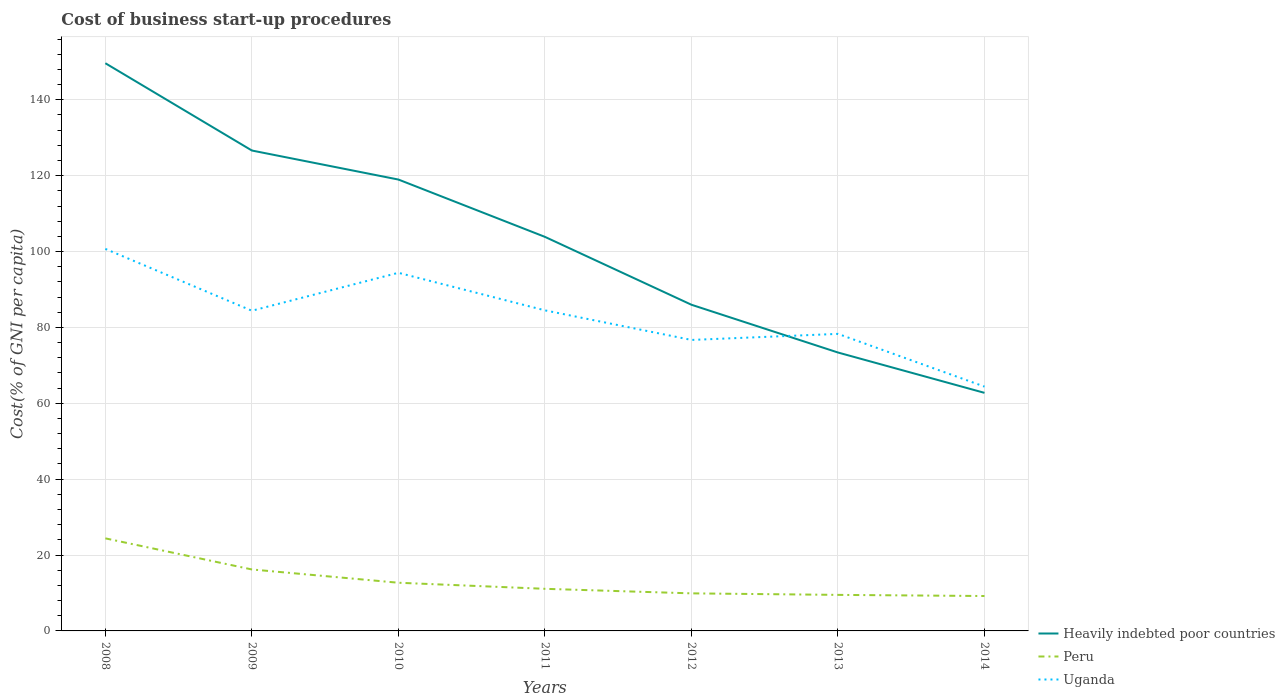Does the line corresponding to Heavily indebted poor countries intersect with the line corresponding to Uganda?
Your answer should be very brief. Yes. Across all years, what is the maximum cost of business start-up procedures in Heavily indebted poor countries?
Ensure brevity in your answer.  62.75. What is the total cost of business start-up procedures in Peru in the graph?
Provide a short and direct response. 7. What is the difference between the highest and the second highest cost of business start-up procedures in Peru?
Provide a succinct answer. 15.2. What is the difference between the highest and the lowest cost of business start-up procedures in Uganda?
Provide a succinct answer. 4. How many years are there in the graph?
Give a very brief answer. 7. Does the graph contain grids?
Provide a short and direct response. Yes. How many legend labels are there?
Your response must be concise. 3. What is the title of the graph?
Offer a terse response. Cost of business start-up procedures. Does "Guam" appear as one of the legend labels in the graph?
Your response must be concise. No. What is the label or title of the Y-axis?
Your answer should be compact. Cost(% of GNI per capita). What is the Cost(% of GNI per capita) in Heavily indebted poor countries in 2008?
Your answer should be compact. 149.64. What is the Cost(% of GNI per capita) of Peru in 2008?
Make the answer very short. 24.4. What is the Cost(% of GNI per capita) of Uganda in 2008?
Your response must be concise. 100.7. What is the Cost(% of GNI per capita) in Heavily indebted poor countries in 2009?
Provide a short and direct response. 126.63. What is the Cost(% of GNI per capita) of Peru in 2009?
Offer a very short reply. 16.2. What is the Cost(% of GNI per capita) of Uganda in 2009?
Ensure brevity in your answer.  84.4. What is the Cost(% of GNI per capita) in Heavily indebted poor countries in 2010?
Your answer should be compact. 118.98. What is the Cost(% of GNI per capita) in Uganda in 2010?
Your answer should be compact. 94.4. What is the Cost(% of GNI per capita) in Heavily indebted poor countries in 2011?
Offer a very short reply. 103.87. What is the Cost(% of GNI per capita) in Peru in 2011?
Your answer should be very brief. 11.1. What is the Cost(% of GNI per capita) in Uganda in 2011?
Give a very brief answer. 84.5. What is the Cost(% of GNI per capita) in Heavily indebted poor countries in 2012?
Offer a terse response. 85.98. What is the Cost(% of GNI per capita) of Uganda in 2012?
Offer a terse response. 76.7. What is the Cost(% of GNI per capita) of Heavily indebted poor countries in 2013?
Ensure brevity in your answer.  73.39. What is the Cost(% of GNI per capita) in Peru in 2013?
Your response must be concise. 9.5. What is the Cost(% of GNI per capita) in Uganda in 2013?
Your answer should be compact. 78.3. What is the Cost(% of GNI per capita) in Heavily indebted poor countries in 2014?
Ensure brevity in your answer.  62.75. What is the Cost(% of GNI per capita) of Peru in 2014?
Ensure brevity in your answer.  9.2. What is the Cost(% of GNI per capita) in Uganda in 2014?
Provide a succinct answer. 64.4. Across all years, what is the maximum Cost(% of GNI per capita) in Heavily indebted poor countries?
Ensure brevity in your answer.  149.64. Across all years, what is the maximum Cost(% of GNI per capita) in Peru?
Provide a succinct answer. 24.4. Across all years, what is the maximum Cost(% of GNI per capita) of Uganda?
Ensure brevity in your answer.  100.7. Across all years, what is the minimum Cost(% of GNI per capita) of Heavily indebted poor countries?
Your answer should be compact. 62.75. Across all years, what is the minimum Cost(% of GNI per capita) in Peru?
Provide a succinct answer. 9.2. Across all years, what is the minimum Cost(% of GNI per capita) of Uganda?
Offer a terse response. 64.4. What is the total Cost(% of GNI per capita) in Heavily indebted poor countries in the graph?
Your response must be concise. 721.24. What is the total Cost(% of GNI per capita) in Peru in the graph?
Keep it short and to the point. 93. What is the total Cost(% of GNI per capita) in Uganda in the graph?
Make the answer very short. 583.4. What is the difference between the Cost(% of GNI per capita) of Heavily indebted poor countries in 2008 and that in 2009?
Make the answer very short. 23.01. What is the difference between the Cost(% of GNI per capita) of Peru in 2008 and that in 2009?
Provide a succinct answer. 8.2. What is the difference between the Cost(% of GNI per capita) of Heavily indebted poor countries in 2008 and that in 2010?
Ensure brevity in your answer.  30.66. What is the difference between the Cost(% of GNI per capita) of Uganda in 2008 and that in 2010?
Your response must be concise. 6.3. What is the difference between the Cost(% of GNI per capita) of Heavily indebted poor countries in 2008 and that in 2011?
Your answer should be very brief. 45.77. What is the difference between the Cost(% of GNI per capita) of Heavily indebted poor countries in 2008 and that in 2012?
Provide a succinct answer. 63.67. What is the difference between the Cost(% of GNI per capita) of Peru in 2008 and that in 2012?
Provide a succinct answer. 14.5. What is the difference between the Cost(% of GNI per capita) in Heavily indebted poor countries in 2008 and that in 2013?
Provide a short and direct response. 76.26. What is the difference between the Cost(% of GNI per capita) of Peru in 2008 and that in 2013?
Offer a very short reply. 14.9. What is the difference between the Cost(% of GNI per capita) in Uganda in 2008 and that in 2013?
Your answer should be very brief. 22.4. What is the difference between the Cost(% of GNI per capita) of Heavily indebted poor countries in 2008 and that in 2014?
Your answer should be very brief. 86.89. What is the difference between the Cost(% of GNI per capita) of Peru in 2008 and that in 2014?
Offer a terse response. 15.2. What is the difference between the Cost(% of GNI per capita) of Uganda in 2008 and that in 2014?
Your answer should be compact. 36.3. What is the difference between the Cost(% of GNI per capita) in Heavily indebted poor countries in 2009 and that in 2010?
Provide a short and direct response. 7.65. What is the difference between the Cost(% of GNI per capita) in Heavily indebted poor countries in 2009 and that in 2011?
Your answer should be compact. 22.76. What is the difference between the Cost(% of GNI per capita) of Peru in 2009 and that in 2011?
Offer a terse response. 5.1. What is the difference between the Cost(% of GNI per capita) in Uganda in 2009 and that in 2011?
Make the answer very short. -0.1. What is the difference between the Cost(% of GNI per capita) in Heavily indebted poor countries in 2009 and that in 2012?
Your answer should be very brief. 40.65. What is the difference between the Cost(% of GNI per capita) of Peru in 2009 and that in 2012?
Your answer should be compact. 6.3. What is the difference between the Cost(% of GNI per capita) in Heavily indebted poor countries in 2009 and that in 2013?
Make the answer very short. 53.24. What is the difference between the Cost(% of GNI per capita) of Heavily indebted poor countries in 2009 and that in 2014?
Give a very brief answer. 63.88. What is the difference between the Cost(% of GNI per capita) of Peru in 2009 and that in 2014?
Ensure brevity in your answer.  7. What is the difference between the Cost(% of GNI per capita) of Heavily indebted poor countries in 2010 and that in 2011?
Keep it short and to the point. 15.11. What is the difference between the Cost(% of GNI per capita) of Uganda in 2010 and that in 2011?
Provide a succinct answer. 9.9. What is the difference between the Cost(% of GNI per capita) of Heavily indebted poor countries in 2010 and that in 2012?
Offer a terse response. 33. What is the difference between the Cost(% of GNI per capita) of Peru in 2010 and that in 2012?
Ensure brevity in your answer.  2.8. What is the difference between the Cost(% of GNI per capita) in Uganda in 2010 and that in 2012?
Provide a succinct answer. 17.7. What is the difference between the Cost(% of GNI per capita) of Heavily indebted poor countries in 2010 and that in 2013?
Offer a very short reply. 45.59. What is the difference between the Cost(% of GNI per capita) in Peru in 2010 and that in 2013?
Your response must be concise. 3.2. What is the difference between the Cost(% of GNI per capita) of Heavily indebted poor countries in 2010 and that in 2014?
Offer a very short reply. 56.23. What is the difference between the Cost(% of GNI per capita) in Heavily indebted poor countries in 2011 and that in 2012?
Offer a terse response. 17.89. What is the difference between the Cost(% of GNI per capita) in Heavily indebted poor countries in 2011 and that in 2013?
Ensure brevity in your answer.  30.48. What is the difference between the Cost(% of GNI per capita) of Uganda in 2011 and that in 2013?
Provide a short and direct response. 6.2. What is the difference between the Cost(% of GNI per capita) of Heavily indebted poor countries in 2011 and that in 2014?
Your answer should be compact. 41.12. What is the difference between the Cost(% of GNI per capita) in Peru in 2011 and that in 2014?
Make the answer very short. 1.9. What is the difference between the Cost(% of GNI per capita) in Uganda in 2011 and that in 2014?
Make the answer very short. 20.1. What is the difference between the Cost(% of GNI per capita) of Heavily indebted poor countries in 2012 and that in 2013?
Ensure brevity in your answer.  12.59. What is the difference between the Cost(% of GNI per capita) of Peru in 2012 and that in 2013?
Provide a succinct answer. 0.4. What is the difference between the Cost(% of GNI per capita) in Heavily indebted poor countries in 2012 and that in 2014?
Provide a succinct answer. 23.22. What is the difference between the Cost(% of GNI per capita) in Peru in 2012 and that in 2014?
Your answer should be compact. 0.7. What is the difference between the Cost(% of GNI per capita) of Uganda in 2012 and that in 2014?
Provide a short and direct response. 12.3. What is the difference between the Cost(% of GNI per capita) of Heavily indebted poor countries in 2013 and that in 2014?
Give a very brief answer. 10.63. What is the difference between the Cost(% of GNI per capita) of Peru in 2013 and that in 2014?
Your answer should be compact. 0.3. What is the difference between the Cost(% of GNI per capita) in Heavily indebted poor countries in 2008 and the Cost(% of GNI per capita) in Peru in 2009?
Your answer should be compact. 133.44. What is the difference between the Cost(% of GNI per capita) in Heavily indebted poor countries in 2008 and the Cost(% of GNI per capita) in Uganda in 2009?
Offer a terse response. 65.24. What is the difference between the Cost(% of GNI per capita) in Peru in 2008 and the Cost(% of GNI per capita) in Uganda in 2009?
Provide a succinct answer. -60. What is the difference between the Cost(% of GNI per capita) of Heavily indebted poor countries in 2008 and the Cost(% of GNI per capita) of Peru in 2010?
Make the answer very short. 136.94. What is the difference between the Cost(% of GNI per capita) in Heavily indebted poor countries in 2008 and the Cost(% of GNI per capita) in Uganda in 2010?
Make the answer very short. 55.24. What is the difference between the Cost(% of GNI per capita) of Peru in 2008 and the Cost(% of GNI per capita) of Uganda in 2010?
Your response must be concise. -70. What is the difference between the Cost(% of GNI per capita) of Heavily indebted poor countries in 2008 and the Cost(% of GNI per capita) of Peru in 2011?
Your answer should be compact. 138.54. What is the difference between the Cost(% of GNI per capita) of Heavily indebted poor countries in 2008 and the Cost(% of GNI per capita) of Uganda in 2011?
Your response must be concise. 65.14. What is the difference between the Cost(% of GNI per capita) in Peru in 2008 and the Cost(% of GNI per capita) in Uganda in 2011?
Offer a very short reply. -60.1. What is the difference between the Cost(% of GNI per capita) of Heavily indebted poor countries in 2008 and the Cost(% of GNI per capita) of Peru in 2012?
Offer a terse response. 139.74. What is the difference between the Cost(% of GNI per capita) in Heavily indebted poor countries in 2008 and the Cost(% of GNI per capita) in Uganda in 2012?
Provide a succinct answer. 72.94. What is the difference between the Cost(% of GNI per capita) of Peru in 2008 and the Cost(% of GNI per capita) of Uganda in 2012?
Ensure brevity in your answer.  -52.3. What is the difference between the Cost(% of GNI per capita) of Heavily indebted poor countries in 2008 and the Cost(% of GNI per capita) of Peru in 2013?
Provide a succinct answer. 140.14. What is the difference between the Cost(% of GNI per capita) in Heavily indebted poor countries in 2008 and the Cost(% of GNI per capita) in Uganda in 2013?
Your answer should be very brief. 71.34. What is the difference between the Cost(% of GNI per capita) in Peru in 2008 and the Cost(% of GNI per capita) in Uganda in 2013?
Provide a succinct answer. -53.9. What is the difference between the Cost(% of GNI per capita) in Heavily indebted poor countries in 2008 and the Cost(% of GNI per capita) in Peru in 2014?
Your response must be concise. 140.44. What is the difference between the Cost(% of GNI per capita) in Heavily indebted poor countries in 2008 and the Cost(% of GNI per capita) in Uganda in 2014?
Keep it short and to the point. 85.24. What is the difference between the Cost(% of GNI per capita) in Heavily indebted poor countries in 2009 and the Cost(% of GNI per capita) in Peru in 2010?
Keep it short and to the point. 113.93. What is the difference between the Cost(% of GNI per capita) of Heavily indebted poor countries in 2009 and the Cost(% of GNI per capita) of Uganda in 2010?
Ensure brevity in your answer.  32.23. What is the difference between the Cost(% of GNI per capita) of Peru in 2009 and the Cost(% of GNI per capita) of Uganda in 2010?
Give a very brief answer. -78.2. What is the difference between the Cost(% of GNI per capita) in Heavily indebted poor countries in 2009 and the Cost(% of GNI per capita) in Peru in 2011?
Make the answer very short. 115.53. What is the difference between the Cost(% of GNI per capita) in Heavily indebted poor countries in 2009 and the Cost(% of GNI per capita) in Uganda in 2011?
Give a very brief answer. 42.13. What is the difference between the Cost(% of GNI per capita) of Peru in 2009 and the Cost(% of GNI per capita) of Uganda in 2011?
Ensure brevity in your answer.  -68.3. What is the difference between the Cost(% of GNI per capita) of Heavily indebted poor countries in 2009 and the Cost(% of GNI per capita) of Peru in 2012?
Provide a short and direct response. 116.73. What is the difference between the Cost(% of GNI per capita) in Heavily indebted poor countries in 2009 and the Cost(% of GNI per capita) in Uganda in 2012?
Ensure brevity in your answer.  49.93. What is the difference between the Cost(% of GNI per capita) of Peru in 2009 and the Cost(% of GNI per capita) of Uganda in 2012?
Your answer should be compact. -60.5. What is the difference between the Cost(% of GNI per capita) of Heavily indebted poor countries in 2009 and the Cost(% of GNI per capita) of Peru in 2013?
Make the answer very short. 117.13. What is the difference between the Cost(% of GNI per capita) in Heavily indebted poor countries in 2009 and the Cost(% of GNI per capita) in Uganda in 2013?
Provide a short and direct response. 48.33. What is the difference between the Cost(% of GNI per capita) in Peru in 2009 and the Cost(% of GNI per capita) in Uganda in 2013?
Offer a very short reply. -62.1. What is the difference between the Cost(% of GNI per capita) of Heavily indebted poor countries in 2009 and the Cost(% of GNI per capita) of Peru in 2014?
Provide a succinct answer. 117.43. What is the difference between the Cost(% of GNI per capita) in Heavily indebted poor countries in 2009 and the Cost(% of GNI per capita) in Uganda in 2014?
Offer a terse response. 62.23. What is the difference between the Cost(% of GNI per capita) in Peru in 2009 and the Cost(% of GNI per capita) in Uganda in 2014?
Make the answer very short. -48.2. What is the difference between the Cost(% of GNI per capita) of Heavily indebted poor countries in 2010 and the Cost(% of GNI per capita) of Peru in 2011?
Provide a succinct answer. 107.88. What is the difference between the Cost(% of GNI per capita) in Heavily indebted poor countries in 2010 and the Cost(% of GNI per capita) in Uganda in 2011?
Your answer should be very brief. 34.48. What is the difference between the Cost(% of GNI per capita) in Peru in 2010 and the Cost(% of GNI per capita) in Uganda in 2011?
Make the answer very short. -71.8. What is the difference between the Cost(% of GNI per capita) of Heavily indebted poor countries in 2010 and the Cost(% of GNI per capita) of Peru in 2012?
Make the answer very short. 109.08. What is the difference between the Cost(% of GNI per capita) of Heavily indebted poor countries in 2010 and the Cost(% of GNI per capita) of Uganda in 2012?
Your response must be concise. 42.28. What is the difference between the Cost(% of GNI per capita) in Peru in 2010 and the Cost(% of GNI per capita) in Uganda in 2012?
Your response must be concise. -64. What is the difference between the Cost(% of GNI per capita) of Heavily indebted poor countries in 2010 and the Cost(% of GNI per capita) of Peru in 2013?
Offer a terse response. 109.48. What is the difference between the Cost(% of GNI per capita) in Heavily indebted poor countries in 2010 and the Cost(% of GNI per capita) in Uganda in 2013?
Offer a very short reply. 40.68. What is the difference between the Cost(% of GNI per capita) of Peru in 2010 and the Cost(% of GNI per capita) of Uganda in 2013?
Ensure brevity in your answer.  -65.6. What is the difference between the Cost(% of GNI per capita) in Heavily indebted poor countries in 2010 and the Cost(% of GNI per capita) in Peru in 2014?
Your answer should be very brief. 109.78. What is the difference between the Cost(% of GNI per capita) in Heavily indebted poor countries in 2010 and the Cost(% of GNI per capita) in Uganda in 2014?
Ensure brevity in your answer.  54.58. What is the difference between the Cost(% of GNI per capita) of Peru in 2010 and the Cost(% of GNI per capita) of Uganda in 2014?
Offer a very short reply. -51.7. What is the difference between the Cost(% of GNI per capita) in Heavily indebted poor countries in 2011 and the Cost(% of GNI per capita) in Peru in 2012?
Ensure brevity in your answer.  93.97. What is the difference between the Cost(% of GNI per capita) in Heavily indebted poor countries in 2011 and the Cost(% of GNI per capita) in Uganda in 2012?
Provide a short and direct response. 27.17. What is the difference between the Cost(% of GNI per capita) in Peru in 2011 and the Cost(% of GNI per capita) in Uganda in 2012?
Offer a very short reply. -65.6. What is the difference between the Cost(% of GNI per capita) of Heavily indebted poor countries in 2011 and the Cost(% of GNI per capita) of Peru in 2013?
Ensure brevity in your answer.  94.37. What is the difference between the Cost(% of GNI per capita) in Heavily indebted poor countries in 2011 and the Cost(% of GNI per capita) in Uganda in 2013?
Your answer should be compact. 25.57. What is the difference between the Cost(% of GNI per capita) in Peru in 2011 and the Cost(% of GNI per capita) in Uganda in 2013?
Provide a short and direct response. -67.2. What is the difference between the Cost(% of GNI per capita) of Heavily indebted poor countries in 2011 and the Cost(% of GNI per capita) of Peru in 2014?
Keep it short and to the point. 94.67. What is the difference between the Cost(% of GNI per capita) in Heavily indebted poor countries in 2011 and the Cost(% of GNI per capita) in Uganda in 2014?
Keep it short and to the point. 39.47. What is the difference between the Cost(% of GNI per capita) in Peru in 2011 and the Cost(% of GNI per capita) in Uganda in 2014?
Your response must be concise. -53.3. What is the difference between the Cost(% of GNI per capita) in Heavily indebted poor countries in 2012 and the Cost(% of GNI per capita) in Peru in 2013?
Keep it short and to the point. 76.48. What is the difference between the Cost(% of GNI per capita) in Heavily indebted poor countries in 2012 and the Cost(% of GNI per capita) in Uganda in 2013?
Offer a terse response. 7.68. What is the difference between the Cost(% of GNI per capita) in Peru in 2012 and the Cost(% of GNI per capita) in Uganda in 2013?
Your response must be concise. -68.4. What is the difference between the Cost(% of GNI per capita) of Heavily indebted poor countries in 2012 and the Cost(% of GNI per capita) of Peru in 2014?
Make the answer very short. 76.78. What is the difference between the Cost(% of GNI per capita) in Heavily indebted poor countries in 2012 and the Cost(% of GNI per capita) in Uganda in 2014?
Ensure brevity in your answer.  21.58. What is the difference between the Cost(% of GNI per capita) of Peru in 2012 and the Cost(% of GNI per capita) of Uganda in 2014?
Your answer should be compact. -54.5. What is the difference between the Cost(% of GNI per capita) of Heavily indebted poor countries in 2013 and the Cost(% of GNI per capita) of Peru in 2014?
Offer a very short reply. 64.19. What is the difference between the Cost(% of GNI per capita) of Heavily indebted poor countries in 2013 and the Cost(% of GNI per capita) of Uganda in 2014?
Make the answer very short. 8.99. What is the difference between the Cost(% of GNI per capita) in Peru in 2013 and the Cost(% of GNI per capita) in Uganda in 2014?
Make the answer very short. -54.9. What is the average Cost(% of GNI per capita) in Heavily indebted poor countries per year?
Offer a terse response. 103.03. What is the average Cost(% of GNI per capita) of Peru per year?
Provide a succinct answer. 13.29. What is the average Cost(% of GNI per capita) of Uganda per year?
Provide a succinct answer. 83.34. In the year 2008, what is the difference between the Cost(% of GNI per capita) in Heavily indebted poor countries and Cost(% of GNI per capita) in Peru?
Provide a short and direct response. 125.24. In the year 2008, what is the difference between the Cost(% of GNI per capita) in Heavily indebted poor countries and Cost(% of GNI per capita) in Uganda?
Provide a short and direct response. 48.94. In the year 2008, what is the difference between the Cost(% of GNI per capita) of Peru and Cost(% of GNI per capita) of Uganda?
Provide a succinct answer. -76.3. In the year 2009, what is the difference between the Cost(% of GNI per capita) in Heavily indebted poor countries and Cost(% of GNI per capita) in Peru?
Provide a short and direct response. 110.43. In the year 2009, what is the difference between the Cost(% of GNI per capita) of Heavily indebted poor countries and Cost(% of GNI per capita) of Uganda?
Your response must be concise. 42.23. In the year 2009, what is the difference between the Cost(% of GNI per capita) of Peru and Cost(% of GNI per capita) of Uganda?
Offer a very short reply. -68.2. In the year 2010, what is the difference between the Cost(% of GNI per capita) of Heavily indebted poor countries and Cost(% of GNI per capita) of Peru?
Offer a very short reply. 106.28. In the year 2010, what is the difference between the Cost(% of GNI per capita) in Heavily indebted poor countries and Cost(% of GNI per capita) in Uganda?
Offer a very short reply. 24.58. In the year 2010, what is the difference between the Cost(% of GNI per capita) in Peru and Cost(% of GNI per capita) in Uganda?
Your answer should be compact. -81.7. In the year 2011, what is the difference between the Cost(% of GNI per capita) in Heavily indebted poor countries and Cost(% of GNI per capita) in Peru?
Give a very brief answer. 92.77. In the year 2011, what is the difference between the Cost(% of GNI per capita) of Heavily indebted poor countries and Cost(% of GNI per capita) of Uganda?
Keep it short and to the point. 19.37. In the year 2011, what is the difference between the Cost(% of GNI per capita) of Peru and Cost(% of GNI per capita) of Uganda?
Ensure brevity in your answer.  -73.4. In the year 2012, what is the difference between the Cost(% of GNI per capita) in Heavily indebted poor countries and Cost(% of GNI per capita) in Peru?
Your answer should be compact. 76.08. In the year 2012, what is the difference between the Cost(% of GNI per capita) in Heavily indebted poor countries and Cost(% of GNI per capita) in Uganda?
Give a very brief answer. 9.28. In the year 2012, what is the difference between the Cost(% of GNI per capita) in Peru and Cost(% of GNI per capita) in Uganda?
Your response must be concise. -66.8. In the year 2013, what is the difference between the Cost(% of GNI per capita) in Heavily indebted poor countries and Cost(% of GNI per capita) in Peru?
Your answer should be compact. 63.89. In the year 2013, what is the difference between the Cost(% of GNI per capita) of Heavily indebted poor countries and Cost(% of GNI per capita) of Uganda?
Provide a succinct answer. -4.91. In the year 2013, what is the difference between the Cost(% of GNI per capita) in Peru and Cost(% of GNI per capita) in Uganda?
Your answer should be very brief. -68.8. In the year 2014, what is the difference between the Cost(% of GNI per capita) in Heavily indebted poor countries and Cost(% of GNI per capita) in Peru?
Offer a very short reply. 53.55. In the year 2014, what is the difference between the Cost(% of GNI per capita) of Heavily indebted poor countries and Cost(% of GNI per capita) of Uganda?
Provide a succinct answer. -1.65. In the year 2014, what is the difference between the Cost(% of GNI per capita) in Peru and Cost(% of GNI per capita) in Uganda?
Your answer should be very brief. -55.2. What is the ratio of the Cost(% of GNI per capita) of Heavily indebted poor countries in 2008 to that in 2009?
Make the answer very short. 1.18. What is the ratio of the Cost(% of GNI per capita) of Peru in 2008 to that in 2009?
Offer a terse response. 1.51. What is the ratio of the Cost(% of GNI per capita) of Uganda in 2008 to that in 2009?
Give a very brief answer. 1.19. What is the ratio of the Cost(% of GNI per capita) of Heavily indebted poor countries in 2008 to that in 2010?
Your response must be concise. 1.26. What is the ratio of the Cost(% of GNI per capita) in Peru in 2008 to that in 2010?
Your answer should be very brief. 1.92. What is the ratio of the Cost(% of GNI per capita) in Uganda in 2008 to that in 2010?
Your response must be concise. 1.07. What is the ratio of the Cost(% of GNI per capita) in Heavily indebted poor countries in 2008 to that in 2011?
Provide a succinct answer. 1.44. What is the ratio of the Cost(% of GNI per capita) of Peru in 2008 to that in 2011?
Your answer should be very brief. 2.2. What is the ratio of the Cost(% of GNI per capita) in Uganda in 2008 to that in 2011?
Provide a succinct answer. 1.19. What is the ratio of the Cost(% of GNI per capita) in Heavily indebted poor countries in 2008 to that in 2012?
Your answer should be very brief. 1.74. What is the ratio of the Cost(% of GNI per capita) in Peru in 2008 to that in 2012?
Your answer should be compact. 2.46. What is the ratio of the Cost(% of GNI per capita) of Uganda in 2008 to that in 2012?
Your answer should be very brief. 1.31. What is the ratio of the Cost(% of GNI per capita) of Heavily indebted poor countries in 2008 to that in 2013?
Provide a succinct answer. 2.04. What is the ratio of the Cost(% of GNI per capita) of Peru in 2008 to that in 2013?
Offer a terse response. 2.57. What is the ratio of the Cost(% of GNI per capita) of Uganda in 2008 to that in 2013?
Make the answer very short. 1.29. What is the ratio of the Cost(% of GNI per capita) of Heavily indebted poor countries in 2008 to that in 2014?
Your answer should be compact. 2.38. What is the ratio of the Cost(% of GNI per capita) of Peru in 2008 to that in 2014?
Your answer should be compact. 2.65. What is the ratio of the Cost(% of GNI per capita) of Uganda in 2008 to that in 2014?
Provide a succinct answer. 1.56. What is the ratio of the Cost(% of GNI per capita) of Heavily indebted poor countries in 2009 to that in 2010?
Make the answer very short. 1.06. What is the ratio of the Cost(% of GNI per capita) in Peru in 2009 to that in 2010?
Offer a terse response. 1.28. What is the ratio of the Cost(% of GNI per capita) of Uganda in 2009 to that in 2010?
Ensure brevity in your answer.  0.89. What is the ratio of the Cost(% of GNI per capita) in Heavily indebted poor countries in 2009 to that in 2011?
Your answer should be very brief. 1.22. What is the ratio of the Cost(% of GNI per capita) of Peru in 2009 to that in 2011?
Ensure brevity in your answer.  1.46. What is the ratio of the Cost(% of GNI per capita) in Heavily indebted poor countries in 2009 to that in 2012?
Offer a terse response. 1.47. What is the ratio of the Cost(% of GNI per capita) of Peru in 2009 to that in 2012?
Ensure brevity in your answer.  1.64. What is the ratio of the Cost(% of GNI per capita) of Uganda in 2009 to that in 2012?
Offer a terse response. 1.1. What is the ratio of the Cost(% of GNI per capita) in Heavily indebted poor countries in 2009 to that in 2013?
Your response must be concise. 1.73. What is the ratio of the Cost(% of GNI per capita) in Peru in 2009 to that in 2013?
Your response must be concise. 1.71. What is the ratio of the Cost(% of GNI per capita) of Uganda in 2009 to that in 2013?
Give a very brief answer. 1.08. What is the ratio of the Cost(% of GNI per capita) in Heavily indebted poor countries in 2009 to that in 2014?
Offer a very short reply. 2.02. What is the ratio of the Cost(% of GNI per capita) of Peru in 2009 to that in 2014?
Make the answer very short. 1.76. What is the ratio of the Cost(% of GNI per capita) in Uganda in 2009 to that in 2014?
Your answer should be compact. 1.31. What is the ratio of the Cost(% of GNI per capita) of Heavily indebted poor countries in 2010 to that in 2011?
Give a very brief answer. 1.15. What is the ratio of the Cost(% of GNI per capita) in Peru in 2010 to that in 2011?
Provide a succinct answer. 1.14. What is the ratio of the Cost(% of GNI per capita) of Uganda in 2010 to that in 2011?
Your answer should be very brief. 1.12. What is the ratio of the Cost(% of GNI per capita) of Heavily indebted poor countries in 2010 to that in 2012?
Offer a very short reply. 1.38. What is the ratio of the Cost(% of GNI per capita) in Peru in 2010 to that in 2012?
Your answer should be compact. 1.28. What is the ratio of the Cost(% of GNI per capita) in Uganda in 2010 to that in 2012?
Your answer should be compact. 1.23. What is the ratio of the Cost(% of GNI per capita) of Heavily indebted poor countries in 2010 to that in 2013?
Make the answer very short. 1.62. What is the ratio of the Cost(% of GNI per capita) of Peru in 2010 to that in 2013?
Make the answer very short. 1.34. What is the ratio of the Cost(% of GNI per capita) in Uganda in 2010 to that in 2013?
Provide a succinct answer. 1.21. What is the ratio of the Cost(% of GNI per capita) of Heavily indebted poor countries in 2010 to that in 2014?
Provide a succinct answer. 1.9. What is the ratio of the Cost(% of GNI per capita) in Peru in 2010 to that in 2014?
Your answer should be very brief. 1.38. What is the ratio of the Cost(% of GNI per capita) of Uganda in 2010 to that in 2014?
Your response must be concise. 1.47. What is the ratio of the Cost(% of GNI per capita) of Heavily indebted poor countries in 2011 to that in 2012?
Offer a very short reply. 1.21. What is the ratio of the Cost(% of GNI per capita) of Peru in 2011 to that in 2012?
Offer a terse response. 1.12. What is the ratio of the Cost(% of GNI per capita) of Uganda in 2011 to that in 2012?
Make the answer very short. 1.1. What is the ratio of the Cost(% of GNI per capita) in Heavily indebted poor countries in 2011 to that in 2013?
Your answer should be compact. 1.42. What is the ratio of the Cost(% of GNI per capita) in Peru in 2011 to that in 2013?
Ensure brevity in your answer.  1.17. What is the ratio of the Cost(% of GNI per capita) of Uganda in 2011 to that in 2013?
Keep it short and to the point. 1.08. What is the ratio of the Cost(% of GNI per capita) in Heavily indebted poor countries in 2011 to that in 2014?
Give a very brief answer. 1.66. What is the ratio of the Cost(% of GNI per capita) of Peru in 2011 to that in 2014?
Offer a very short reply. 1.21. What is the ratio of the Cost(% of GNI per capita) in Uganda in 2011 to that in 2014?
Ensure brevity in your answer.  1.31. What is the ratio of the Cost(% of GNI per capita) in Heavily indebted poor countries in 2012 to that in 2013?
Give a very brief answer. 1.17. What is the ratio of the Cost(% of GNI per capita) in Peru in 2012 to that in 2013?
Offer a terse response. 1.04. What is the ratio of the Cost(% of GNI per capita) of Uganda in 2012 to that in 2013?
Offer a very short reply. 0.98. What is the ratio of the Cost(% of GNI per capita) in Heavily indebted poor countries in 2012 to that in 2014?
Provide a succinct answer. 1.37. What is the ratio of the Cost(% of GNI per capita) of Peru in 2012 to that in 2014?
Ensure brevity in your answer.  1.08. What is the ratio of the Cost(% of GNI per capita) of Uganda in 2012 to that in 2014?
Your answer should be compact. 1.19. What is the ratio of the Cost(% of GNI per capita) in Heavily indebted poor countries in 2013 to that in 2014?
Keep it short and to the point. 1.17. What is the ratio of the Cost(% of GNI per capita) of Peru in 2013 to that in 2014?
Offer a terse response. 1.03. What is the ratio of the Cost(% of GNI per capita) in Uganda in 2013 to that in 2014?
Your answer should be compact. 1.22. What is the difference between the highest and the second highest Cost(% of GNI per capita) of Heavily indebted poor countries?
Offer a very short reply. 23.01. What is the difference between the highest and the second highest Cost(% of GNI per capita) in Peru?
Provide a succinct answer. 8.2. What is the difference between the highest and the lowest Cost(% of GNI per capita) of Heavily indebted poor countries?
Offer a terse response. 86.89. What is the difference between the highest and the lowest Cost(% of GNI per capita) of Peru?
Ensure brevity in your answer.  15.2. What is the difference between the highest and the lowest Cost(% of GNI per capita) in Uganda?
Make the answer very short. 36.3. 